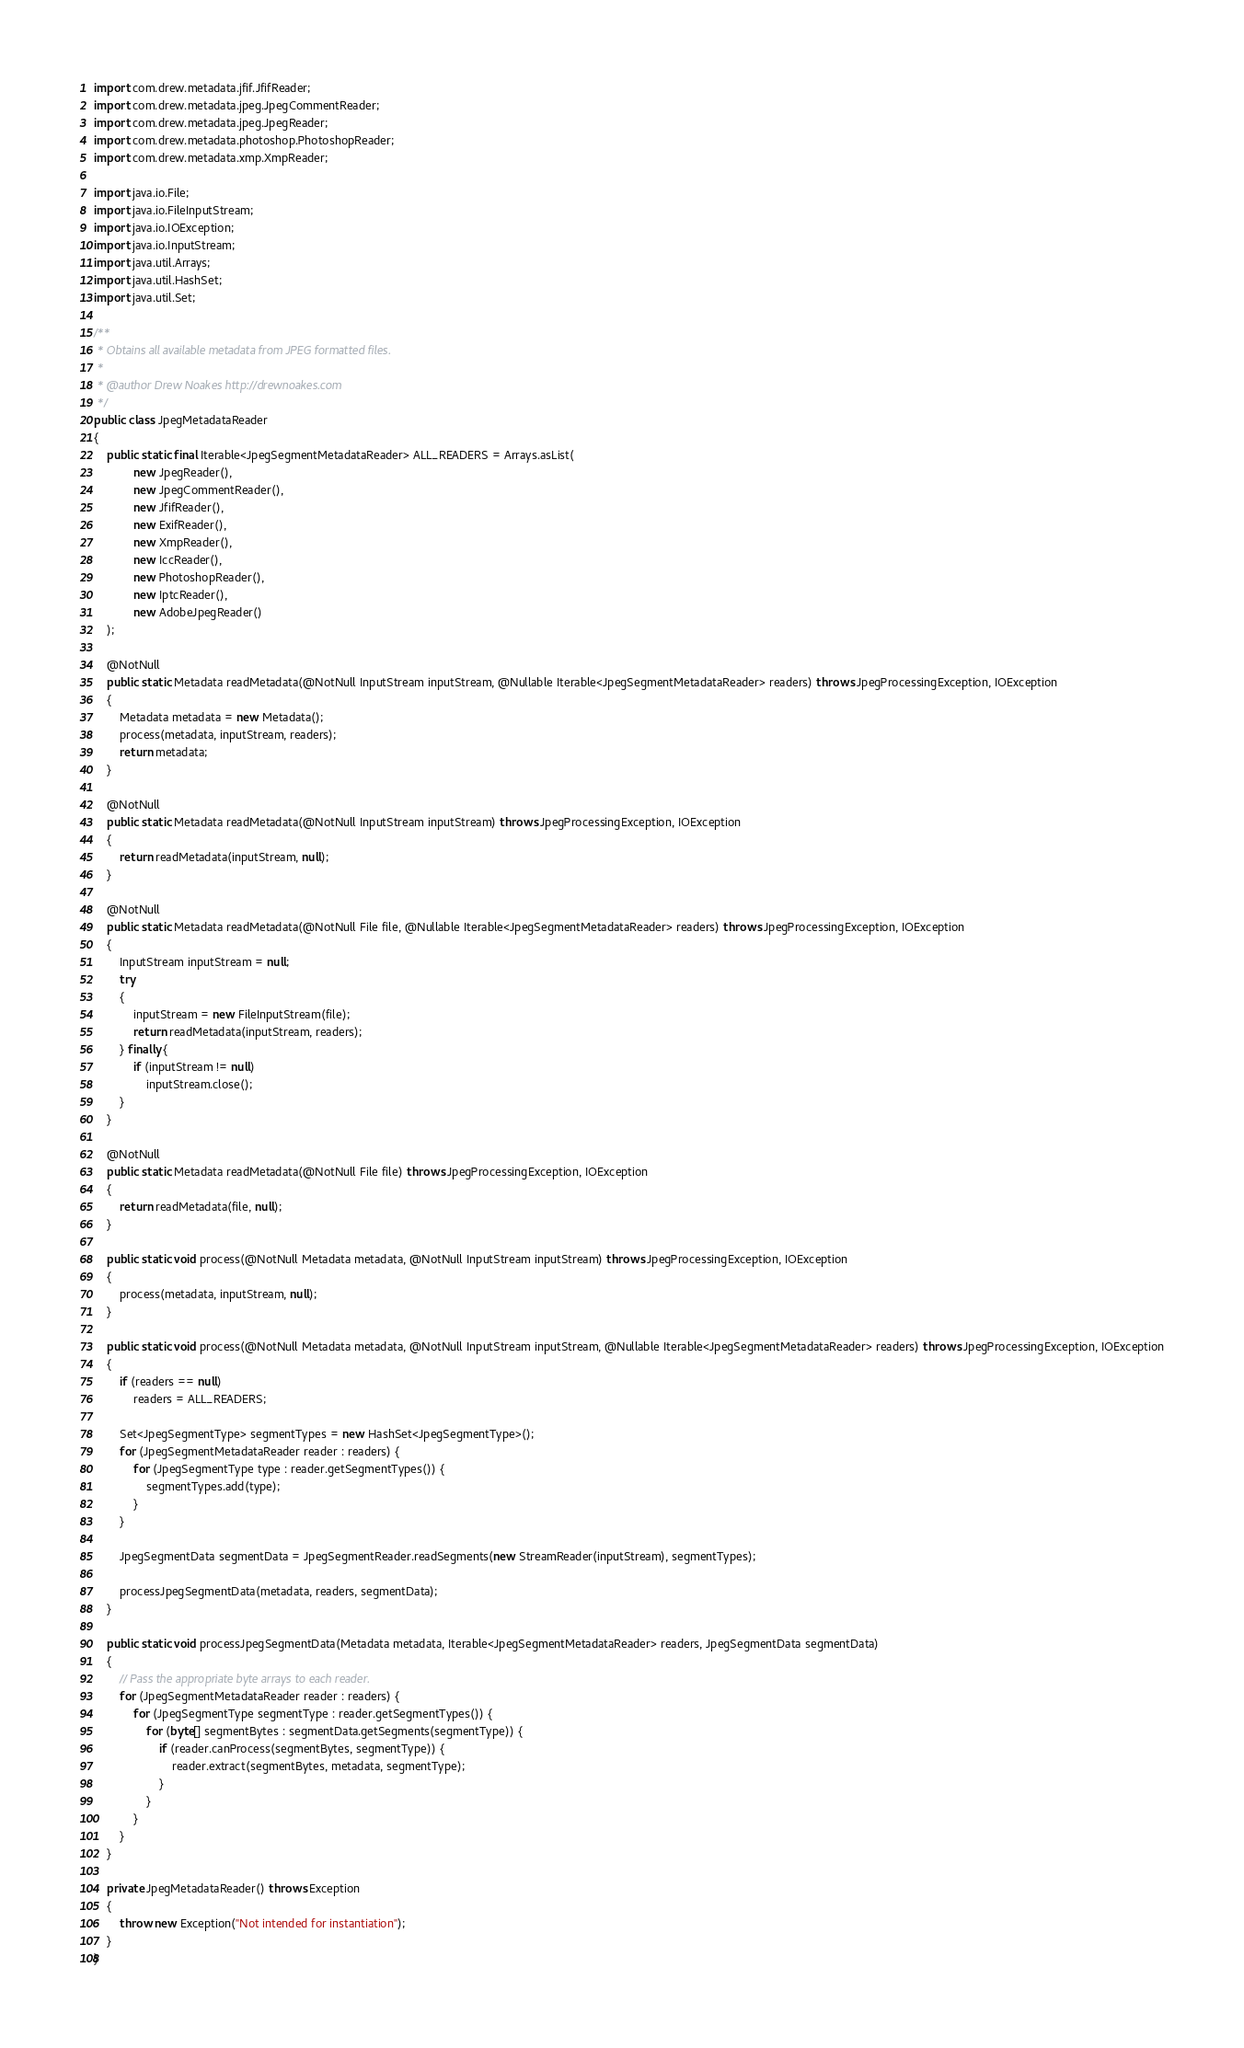<code> <loc_0><loc_0><loc_500><loc_500><_Java_>import com.drew.metadata.jfif.JfifReader;
import com.drew.metadata.jpeg.JpegCommentReader;
import com.drew.metadata.jpeg.JpegReader;
import com.drew.metadata.photoshop.PhotoshopReader;
import com.drew.metadata.xmp.XmpReader;

import java.io.File;
import java.io.FileInputStream;
import java.io.IOException;
import java.io.InputStream;
import java.util.Arrays;
import java.util.HashSet;
import java.util.Set;

/**
 * Obtains all available metadata from JPEG formatted files.
 *
 * @author Drew Noakes http://drewnoakes.com
 */
public class JpegMetadataReader
{
    public static final Iterable<JpegSegmentMetadataReader> ALL_READERS = Arrays.asList(
            new JpegReader(),
            new JpegCommentReader(),
            new JfifReader(),
            new ExifReader(),
            new XmpReader(),
            new IccReader(),
            new PhotoshopReader(),
            new IptcReader(),
            new AdobeJpegReader()
    );

    @NotNull
    public static Metadata readMetadata(@NotNull InputStream inputStream, @Nullable Iterable<JpegSegmentMetadataReader> readers) throws JpegProcessingException, IOException
    {
        Metadata metadata = new Metadata();
        process(metadata, inputStream, readers);
        return metadata;
    }

    @NotNull
    public static Metadata readMetadata(@NotNull InputStream inputStream) throws JpegProcessingException, IOException
    {
        return readMetadata(inputStream, null);
    }

    @NotNull
    public static Metadata readMetadata(@NotNull File file, @Nullable Iterable<JpegSegmentMetadataReader> readers) throws JpegProcessingException, IOException
    {
        InputStream inputStream = null;
        try
        {
            inputStream = new FileInputStream(file);
            return readMetadata(inputStream, readers);
        } finally {
            if (inputStream != null)
                inputStream.close();
        }
    }

    @NotNull
    public static Metadata readMetadata(@NotNull File file) throws JpegProcessingException, IOException
    {
        return readMetadata(file, null);
    }

    public static void process(@NotNull Metadata metadata, @NotNull InputStream inputStream) throws JpegProcessingException, IOException
    {
        process(metadata, inputStream, null);
    }

    public static void process(@NotNull Metadata metadata, @NotNull InputStream inputStream, @Nullable Iterable<JpegSegmentMetadataReader> readers) throws JpegProcessingException, IOException
    {
        if (readers == null)
            readers = ALL_READERS;

        Set<JpegSegmentType> segmentTypes = new HashSet<JpegSegmentType>();
        for (JpegSegmentMetadataReader reader : readers) {
            for (JpegSegmentType type : reader.getSegmentTypes()) {
                segmentTypes.add(type);
            }
        }

        JpegSegmentData segmentData = JpegSegmentReader.readSegments(new StreamReader(inputStream), segmentTypes);

        processJpegSegmentData(metadata, readers, segmentData);
    }

    public static void processJpegSegmentData(Metadata metadata, Iterable<JpegSegmentMetadataReader> readers, JpegSegmentData segmentData)
    {
        // Pass the appropriate byte arrays to each reader.
        for (JpegSegmentMetadataReader reader : readers) {
            for (JpegSegmentType segmentType : reader.getSegmentTypes()) {
                for (byte[] segmentBytes : segmentData.getSegments(segmentType)) {
                    if (reader.canProcess(segmentBytes, segmentType)) {
                        reader.extract(segmentBytes, metadata, segmentType);
                    }
                }
            }
        }
    }

    private JpegMetadataReader() throws Exception
    {
        throw new Exception("Not intended for instantiation");
    }
}</code> 